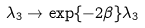Convert formula to latex. <formula><loc_0><loc_0><loc_500><loc_500>\lambda _ { 3 } \rightarrow \exp \{ - 2 \beta \} \lambda _ { 3 }</formula> 